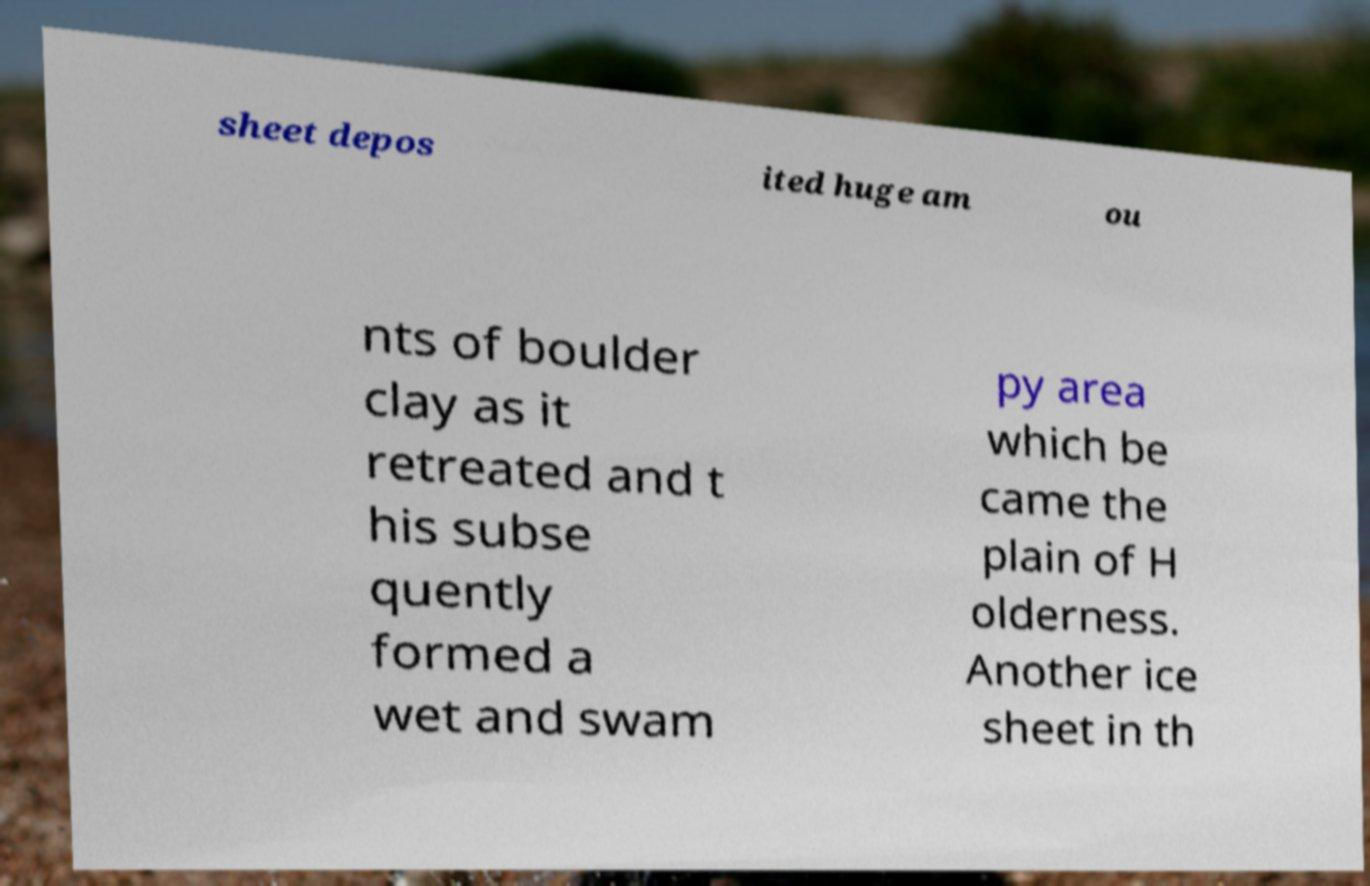What messages or text are displayed in this image? I need them in a readable, typed format. sheet depos ited huge am ou nts of boulder clay as it retreated and t his subse quently formed a wet and swam py area which be came the plain of H olderness. Another ice sheet in th 